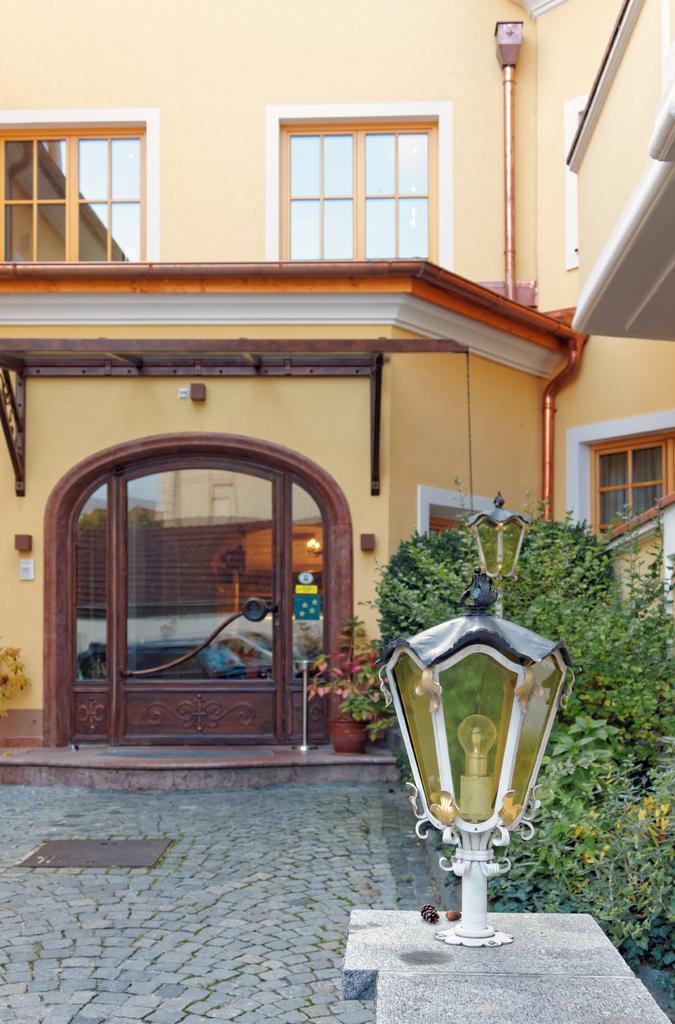In one or two sentences, can you explain what this image depicts? In this picture there is a building with a door and windows. At the top, there is a pipe. At the bottom, there is a light. Behind it, there are plants. At the bottom left, there are tiles. 